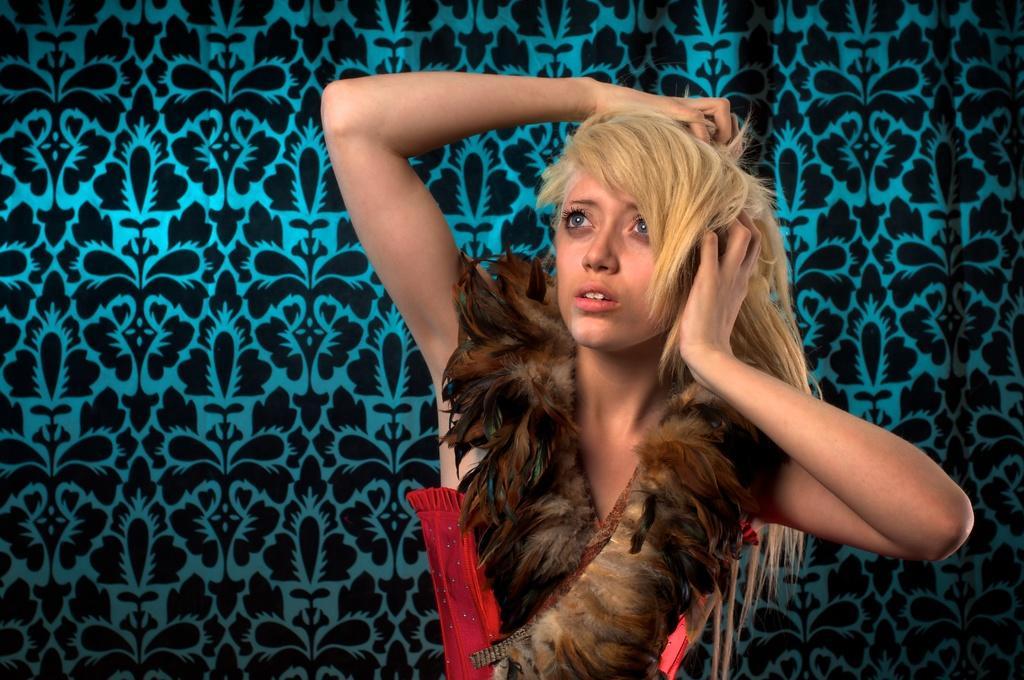Please provide a concise description of this image. In the center of the image, we can see a lady wearing feathers dress and in the background, there is a wall. 